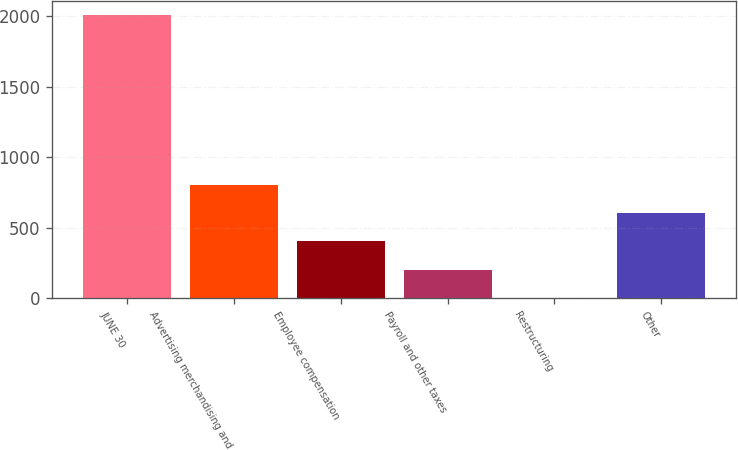Convert chart to OTSL. <chart><loc_0><loc_0><loc_500><loc_500><bar_chart><fcel>JUNE 30<fcel>Advertising merchandising and<fcel>Employee compensation<fcel>Payroll and other taxes<fcel>Restructuring<fcel>Other<nl><fcel>2008<fcel>803.44<fcel>401.92<fcel>201.16<fcel>0.4<fcel>602.68<nl></chart> 